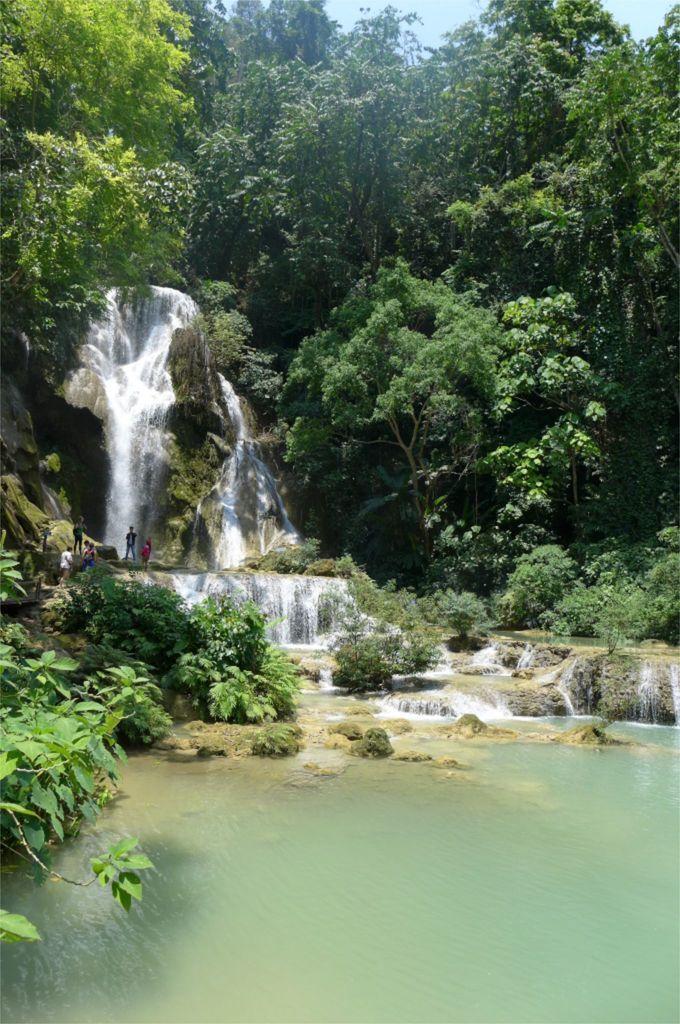Could you give a brief overview of what you see in this image? In this image we can see the waterfalls and there are few people and we can see some plants and trees and we can see some rocks. 